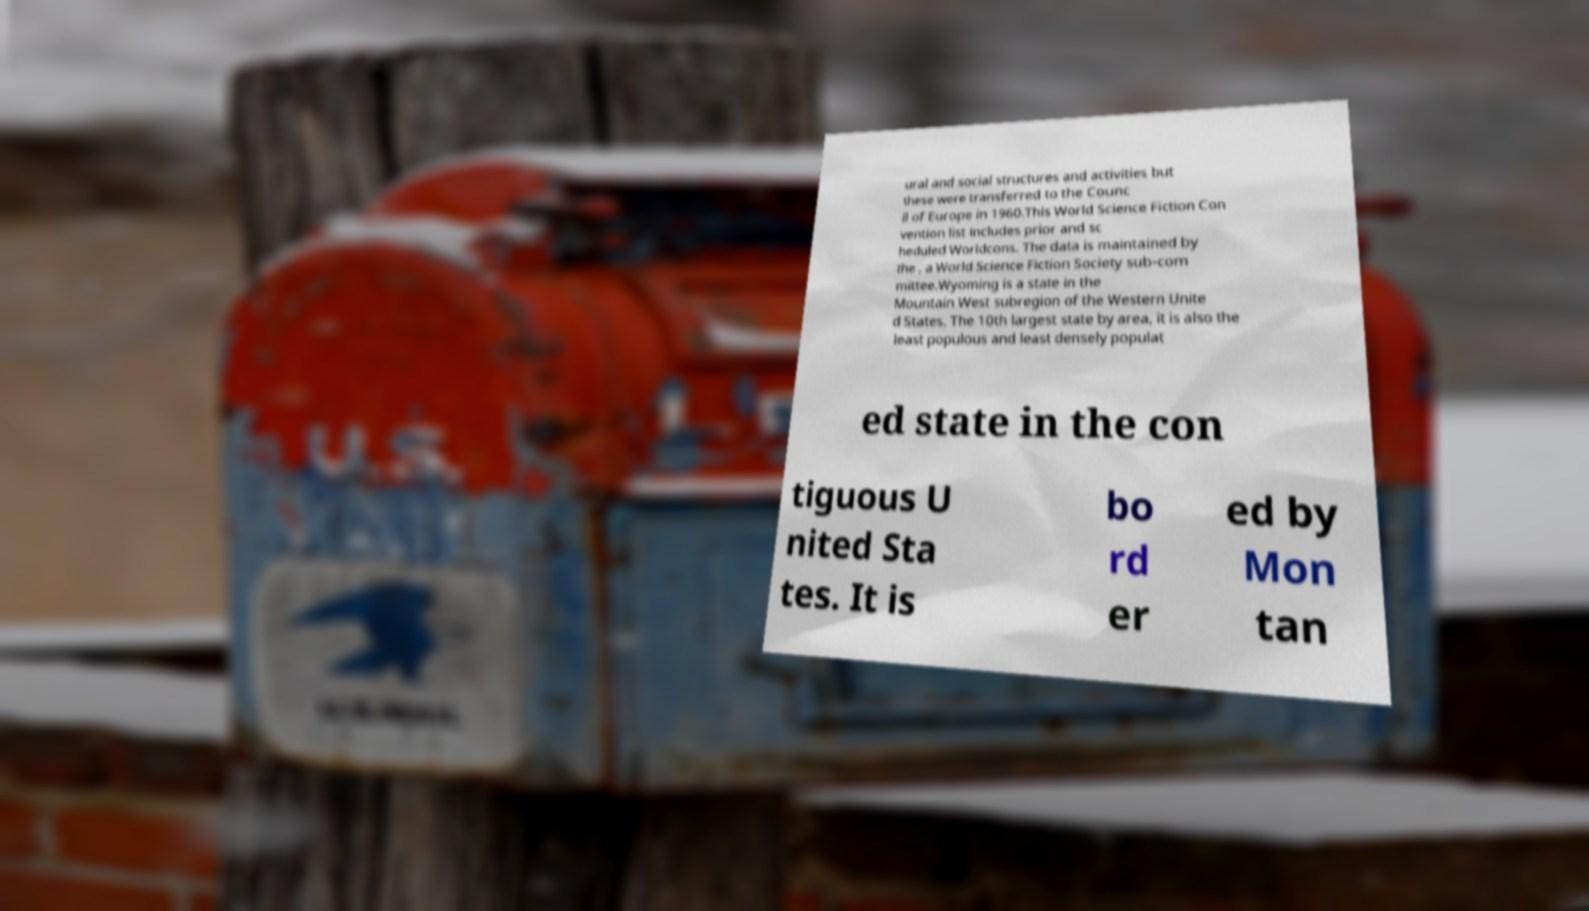For documentation purposes, I need the text within this image transcribed. Could you provide that? ural and social structures and activities but these were transferred to the Counc il of Europe in 1960.This World Science Fiction Con vention list includes prior and sc heduled Worldcons. The data is maintained by the , a World Science Fiction Society sub-com mittee.Wyoming is a state in the Mountain West subregion of the Western Unite d States. The 10th largest state by area, it is also the least populous and least densely populat ed state in the con tiguous U nited Sta tes. It is bo rd er ed by Mon tan 